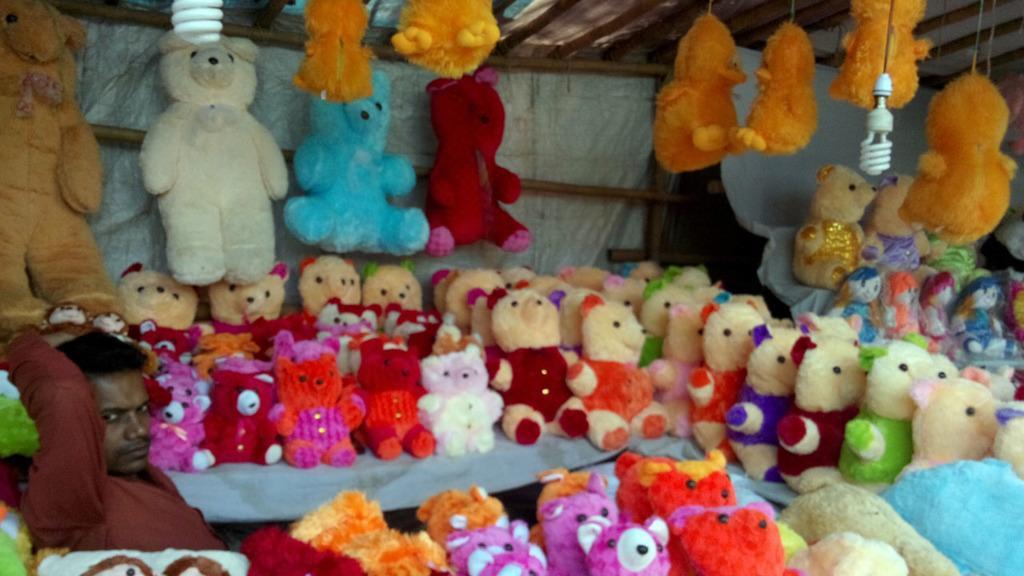In one or two sentences, can you explain what this image depicts? On the left side of the image we can see a man sitting. There is a table and we can see soft toys placed on the table. In the background there is a shed and we can see toys placed on the rod. At the top there are lights. 